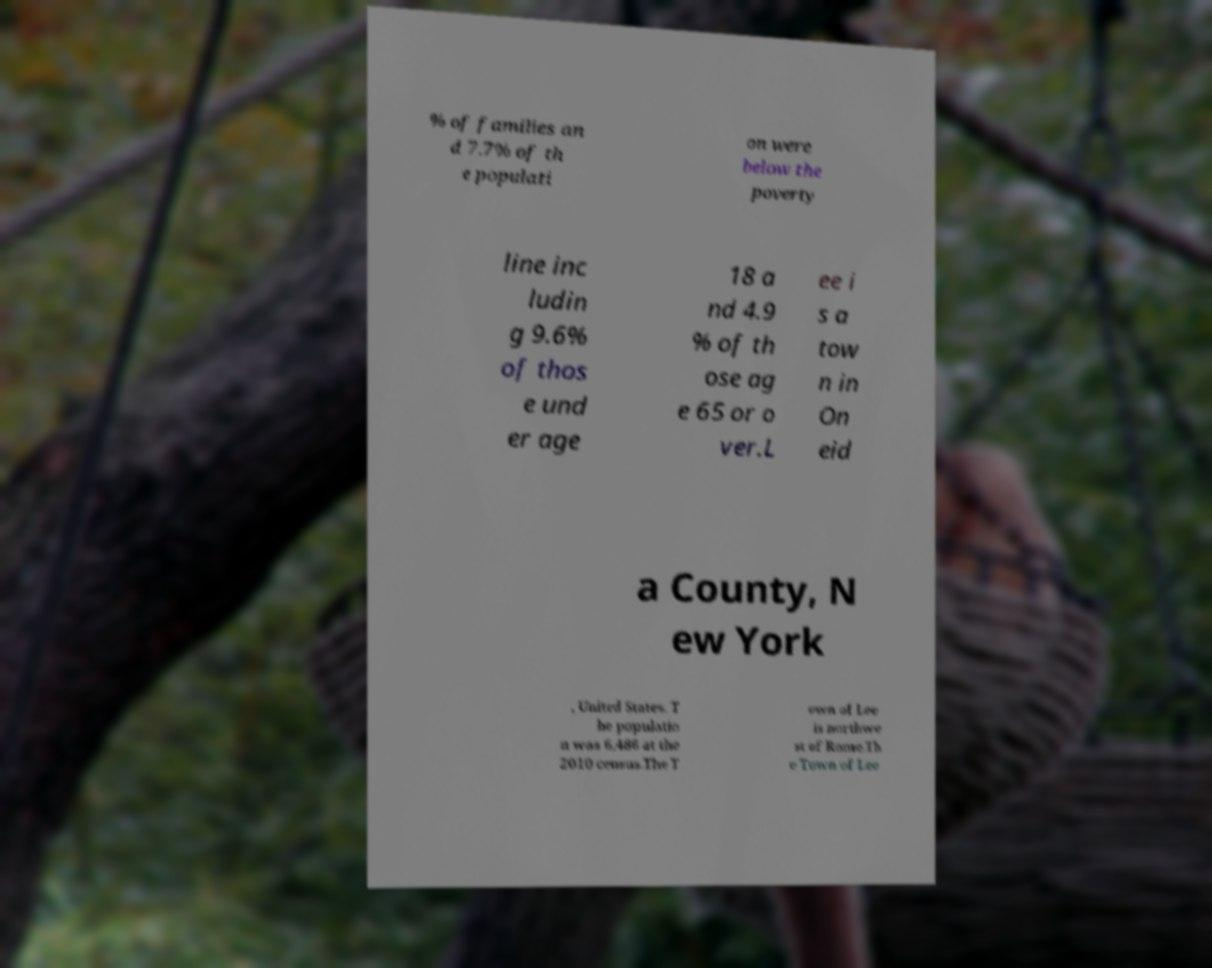Can you accurately transcribe the text from the provided image for me? % of families an d 7.7% of th e populati on were below the poverty line inc ludin g 9.6% of thos e und er age 18 a nd 4.9 % of th ose ag e 65 or o ver.L ee i s a tow n in On eid a County, N ew York , United States. T he populatio n was 6,486 at the 2010 census.The T own of Lee is northwe st of Rome.Th e Town of Lee 